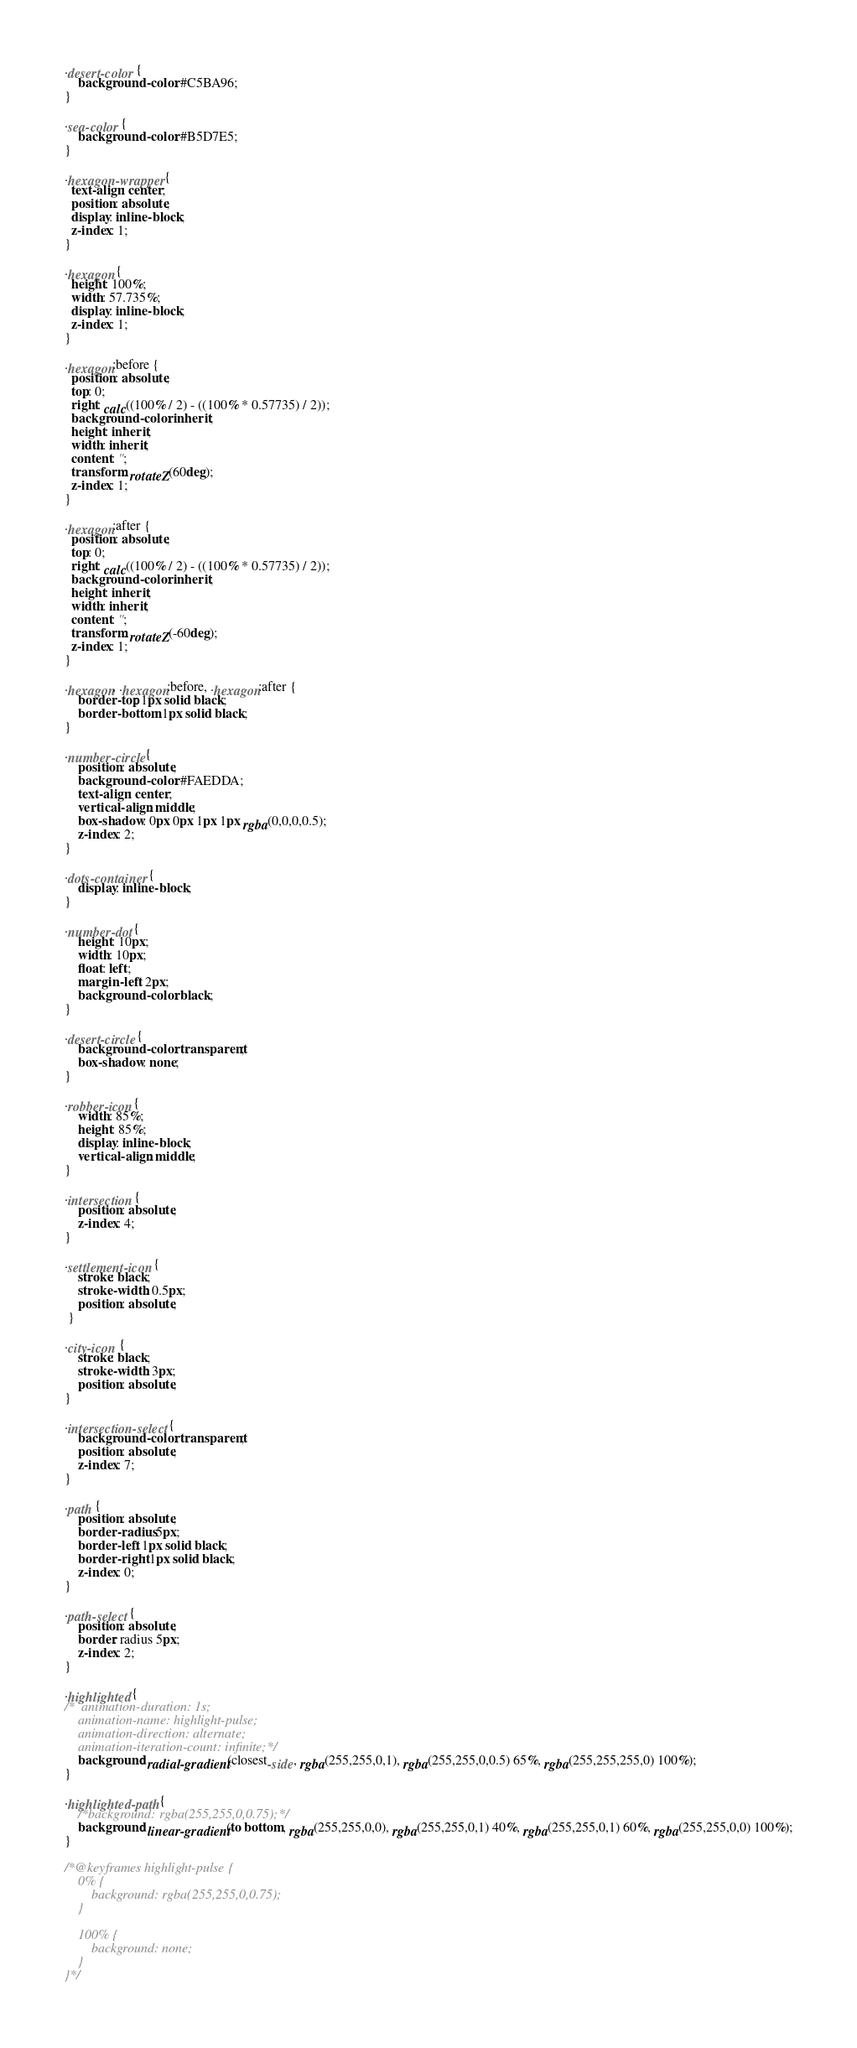Convert code to text. <code><loc_0><loc_0><loc_500><loc_500><_CSS_>
.desert-color {
	background-color: #C5BA96;
}

.sea-color {
	background-color: #B5D7E5;
}

.hexagon-wrapper {
  text-align: center;
  position: absolute;
  display: inline-block;
  z-index: 1;
}

.hexagon {
  height: 100%;
  width: 57.735%;
  display: inline-block;
  z-index: 1;
}

.hexagon:before {
  position: absolute;
  top: 0;
  right: calc((100% / 2) - ((100% * 0.57735) / 2));
  background-color: inherit;
  height: inherit;
  width: inherit;
  content: '';
  transform: rotateZ(60deg);
  z-index: 1;
}

.hexagon:after {
  position: absolute;
  top: 0;
  right: calc((100% / 2) - ((100% * 0.57735) / 2));
  background-color: inherit;
  height: inherit;
  width: inherit;
  content: '';
  transform: rotateZ(-60deg);
  z-index: 1;
}

.hexagon, .hexagon:before, .hexagon:after {
	border-top: 1px solid black;
	border-bottom: 1px solid black;
}

.number-circle {
	position: absolute;
	background-color: #FAEDDA;
	text-align: center;
	vertical-align: middle;
	box-shadow: 0px 0px 1px 1px rgba(0,0,0,0.5);
	z-index: 2;
}

.dots-container {
	display: inline-block;
}

.number-dot {
	height: 10px;
  	width: 10px;
  	float: left;
  	margin-left: 2px;
  	background-color: black;
}

.desert-circle {
	background-color: transparent;
	box-shadow: none;
}

.robber-icon {
	width: 85%;
	height: 85%;
	display: inline-block;
	vertical-align: middle;
}

.intersection {
	position: absolute;
	z-index: 4;
}

.settlement-icon {
	stroke: black;
	stroke-width: 0.5px;
	position: absolute;
 }
 
.city-icon {
	stroke: black;
	stroke-width: 3px;
	position: absolute;
}

.intersection-select {
	background-color: transparent;
	position: absolute;
	z-index: 7;
}

.path {
	position: absolute;
	border-radius: 5px;
	border-left: 1px solid black;
	border-right: 1px solid black;
	z-index: 0;
}

.path-select {
	position: absolute;
	border: radius 5px;
	z-index: 2;
}

.highlighted {
/*	animation-duration: 1s;
	animation-name: highlight-pulse;
	animation-direction: alternate;
	animation-iteration-count: infinite;*/
	background: radial-gradient(closest-side, rgba(255,255,0,1), rgba(255,255,0,0.5) 65%, rgba(255,255,255,0) 100%);
}

.highlighted-path {
	/*background: rgba(255,255,0,0.75);*/
	background: linear-gradient(to bottom, rgba(255,255,0,0), rgba(255,255,0,1) 40%, rgba(255,255,0,1) 60%, rgba(255,255,0,0) 100%);
}

/*@keyframes highlight-pulse {
	0% {
		background: rgba(255,255,0,0.75);
	}

	100% {
		background: none;
	}
}*/
</code> 